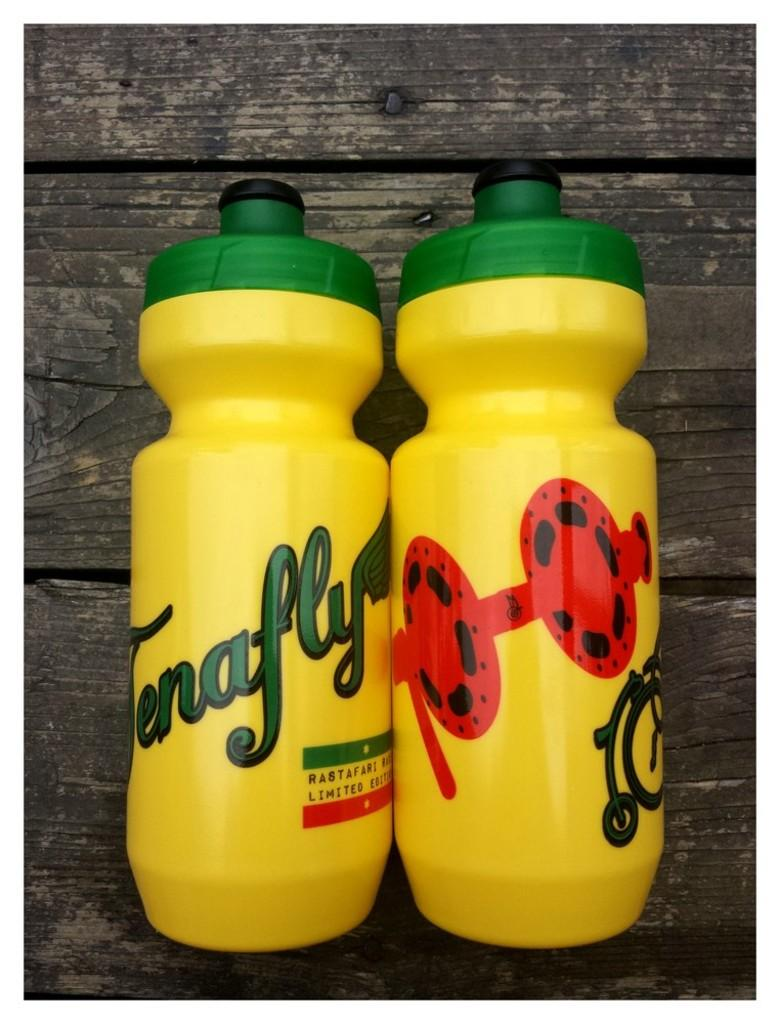<image>
Render a clear and concise summary of the photo. Two limited edition yellow water bottles placed on a wooden surface. 